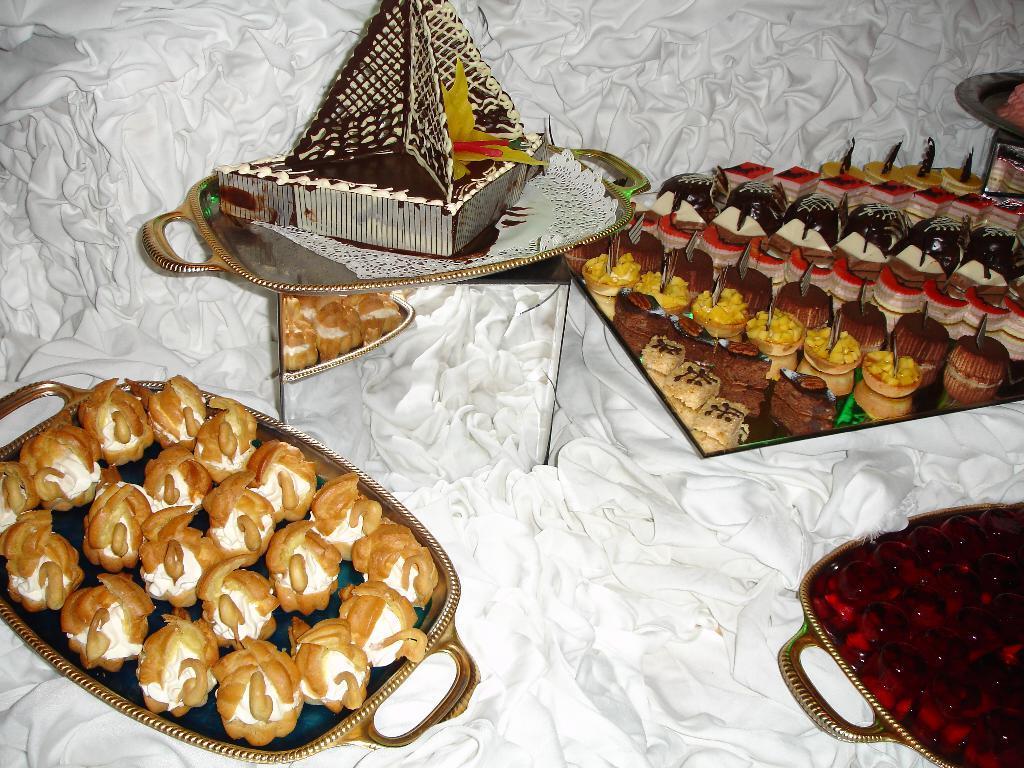In one or two sentences, can you explain what this image depicts? In this image I can see many trays with food. These traits are on the white color cloth. I can see these food items are very colorful. 